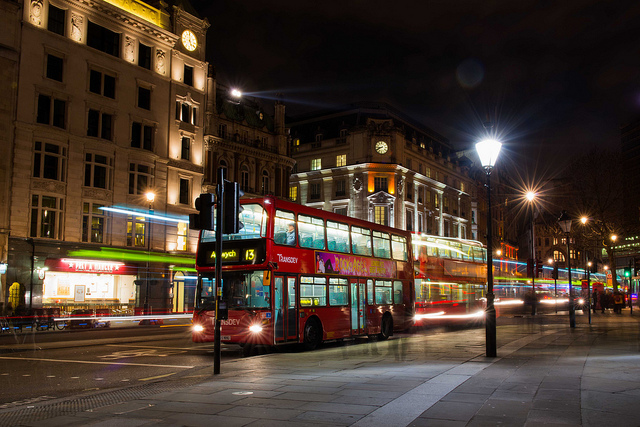Identify the text contained in this image. 101 13 